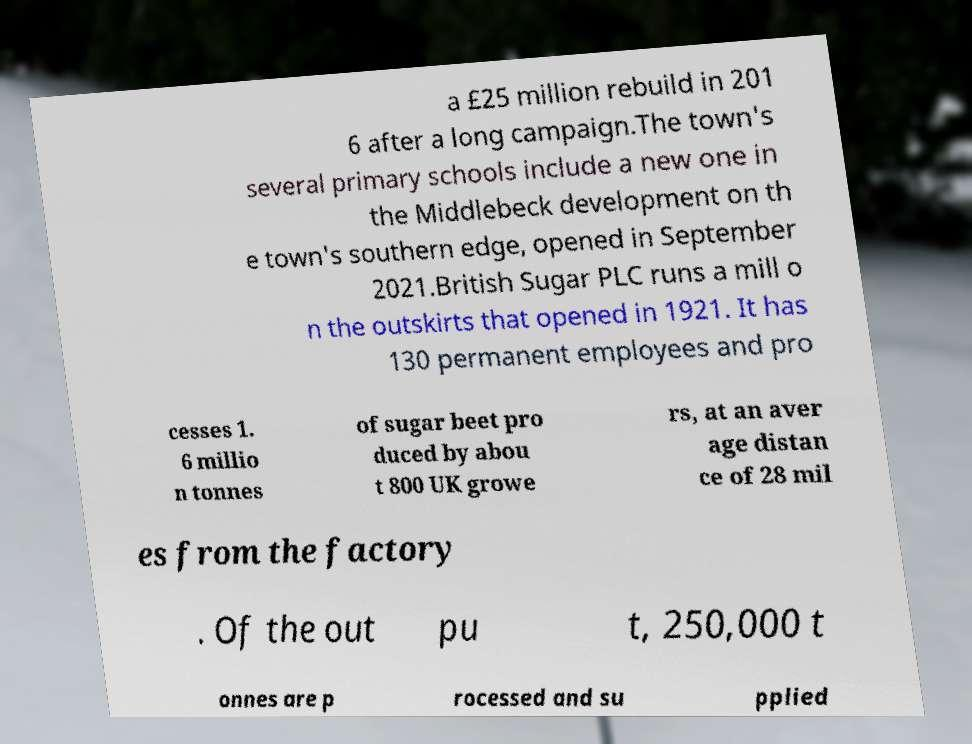Could you extract and type out the text from this image? a £25 million rebuild in 201 6 after a long campaign.The town's several primary schools include a new one in the Middlebeck development on th e town's southern edge, opened in September 2021.British Sugar PLC runs a mill o n the outskirts that opened in 1921. It has 130 permanent employees and pro cesses 1. 6 millio n tonnes of sugar beet pro duced by abou t 800 UK growe rs, at an aver age distan ce of 28 mil es from the factory . Of the out pu t, 250,000 t onnes are p rocessed and su pplied 